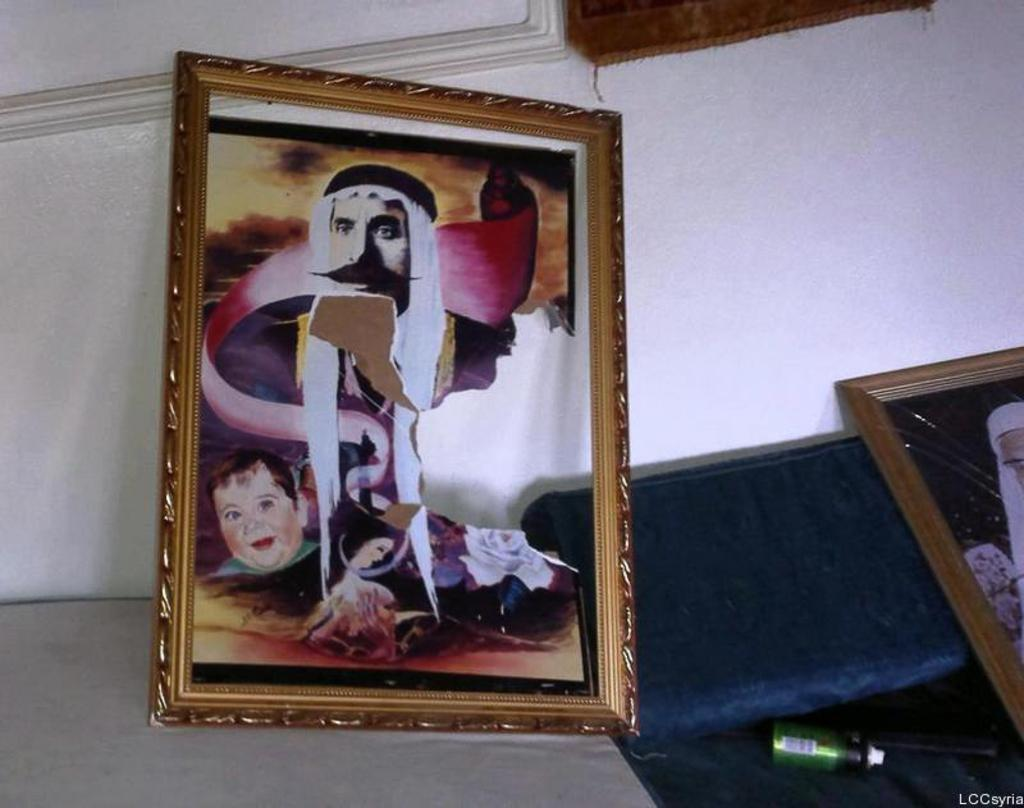What is placed on the white surface in the image? There are frames on a white surface in the image. What is the color of the background in the image? The background of the image is a white color wall. What can be seen at the bottom of the image? There is a small bottle at the bottom of the image. Is there any additional marking or feature in the image? Yes, there is a watermark in the image. How does the part of the frame express anger in the image? There is no part of the frame expressing anger in the image, as frames are inanimate objects and do not have emotions. What type of bubble can be seen in the image? There are no bubbles present in the image. 